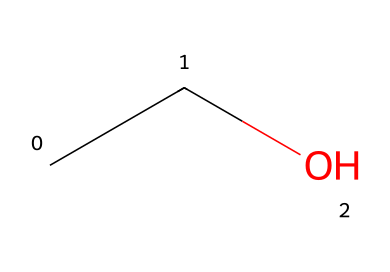how many carbon atoms are in the structure? The SMILES representation "CCO" indicates there are two carbon (C) atoms, as each "C" character corresponds to a carbon in the molecular structure.
Answer: 2 what is the functional group present in this molecule? The "C" connected to "O" (the oxygen) indicates the presence of a hydroxyl (-OH) group, defining the molecule as an alcohol.
Answer: alcohol is this compound polar or nonpolar? The presence of the hydroxyl group (-OH) suggests that the molecule can form hydrogen bonds, contributing to its polarity. The carbon chain is relatively short, which also supports polarity due to the oxygen atom.
Answer: polar what is the primary use of ethanol in hemp extraction? Ethanol is commonly used as a solvent in hemp extraction processes due to its effectiveness in dissolving a wide range of compounds, making it suitable for extracting cannabinoids and terpenes from hemp.
Answer: solvent does this molecule possess flammable properties? The molecular structure contains carbon and hydrogen, and the presence of the hydroxyl group does not significantly alter the flammability; therefore, ethanol is classified as a flammable liquid.
Answer: yes what is the molecular weight of ethanol? The molecular formula for ethanol (C2H6O) indicates it has a molecular weight calculated by summing the atomic weights of all its atoms: (2 x 12.01) + (6 x 1.008) + (1 x 16.00) = 46.07 grams per mole.
Answer: 46.07 